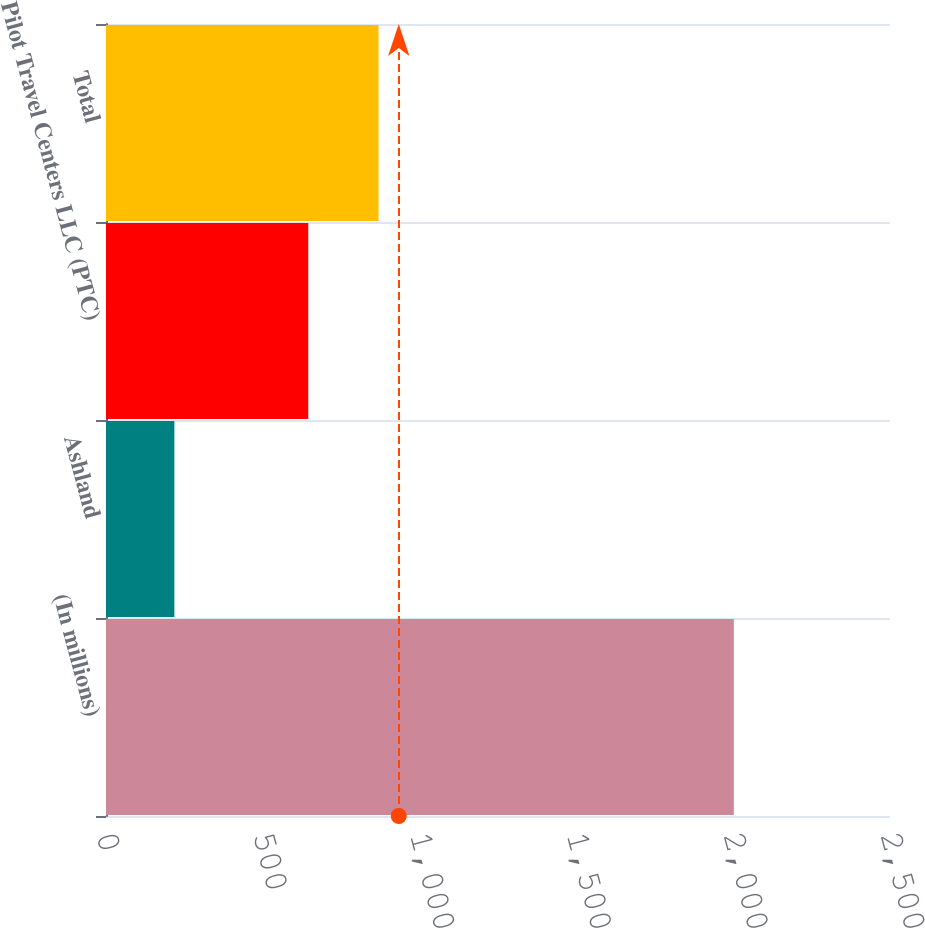<chart> <loc_0><loc_0><loc_500><loc_500><bar_chart><fcel>(In millions)<fcel>Ashland<fcel>Pilot Travel Centers LLC (PTC)<fcel>Total<nl><fcel>2002<fcel>218<fcel>645<fcel>869<nl></chart> 